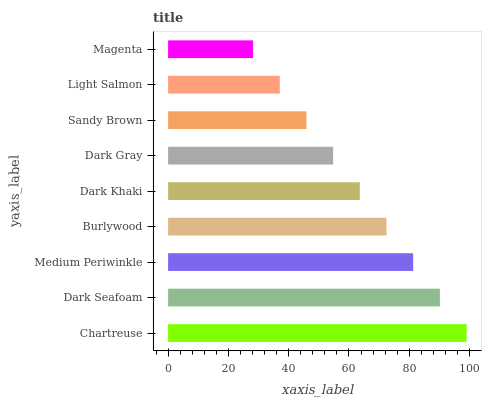Is Magenta the minimum?
Answer yes or no. Yes. Is Chartreuse the maximum?
Answer yes or no. Yes. Is Dark Seafoam the minimum?
Answer yes or no. No. Is Dark Seafoam the maximum?
Answer yes or no. No. Is Chartreuse greater than Dark Seafoam?
Answer yes or no. Yes. Is Dark Seafoam less than Chartreuse?
Answer yes or no. Yes. Is Dark Seafoam greater than Chartreuse?
Answer yes or no. No. Is Chartreuse less than Dark Seafoam?
Answer yes or no. No. Is Dark Khaki the high median?
Answer yes or no. Yes. Is Dark Khaki the low median?
Answer yes or no. Yes. Is Magenta the high median?
Answer yes or no. No. Is Chartreuse the low median?
Answer yes or no. No. 